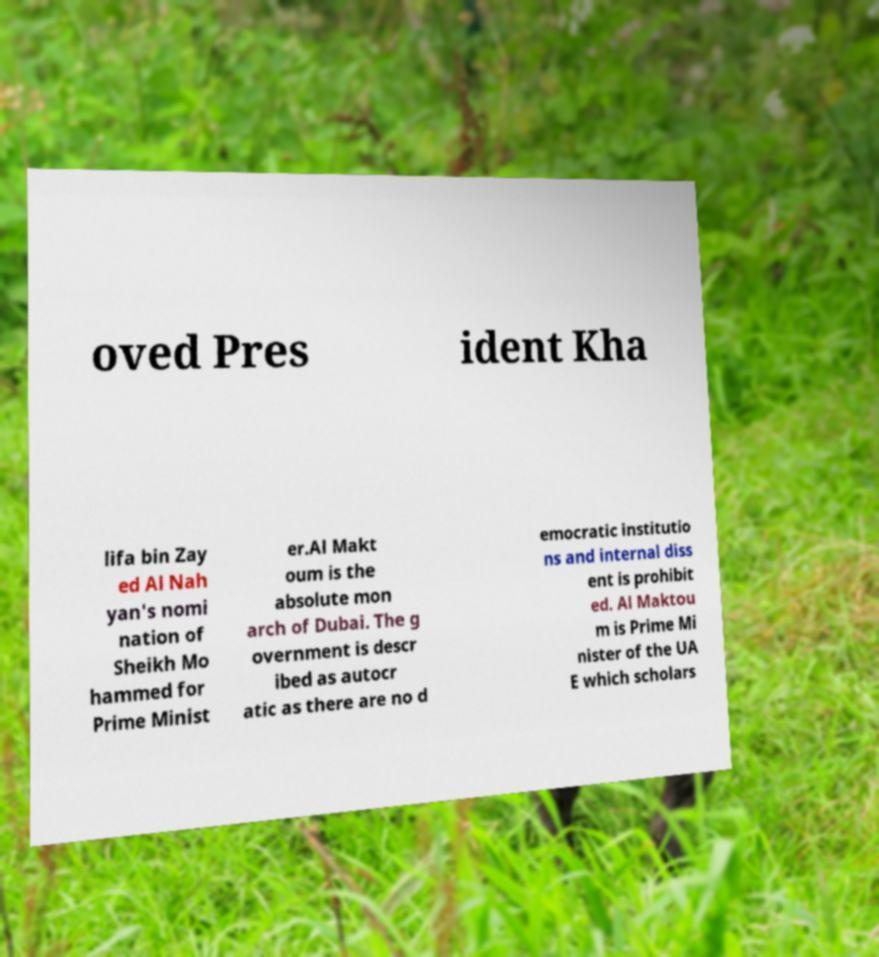There's text embedded in this image that I need extracted. Can you transcribe it verbatim? oved Pres ident Kha lifa bin Zay ed Al Nah yan's nomi nation of Sheikh Mo hammed for Prime Minist er.Al Makt oum is the absolute mon arch of Dubai. The g overnment is descr ibed as autocr atic as there are no d emocratic institutio ns and internal diss ent is prohibit ed. Al Maktou m is Prime Mi nister of the UA E which scholars 